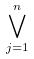<formula> <loc_0><loc_0><loc_500><loc_500>\bigvee _ { j = 1 } ^ { n }</formula> 